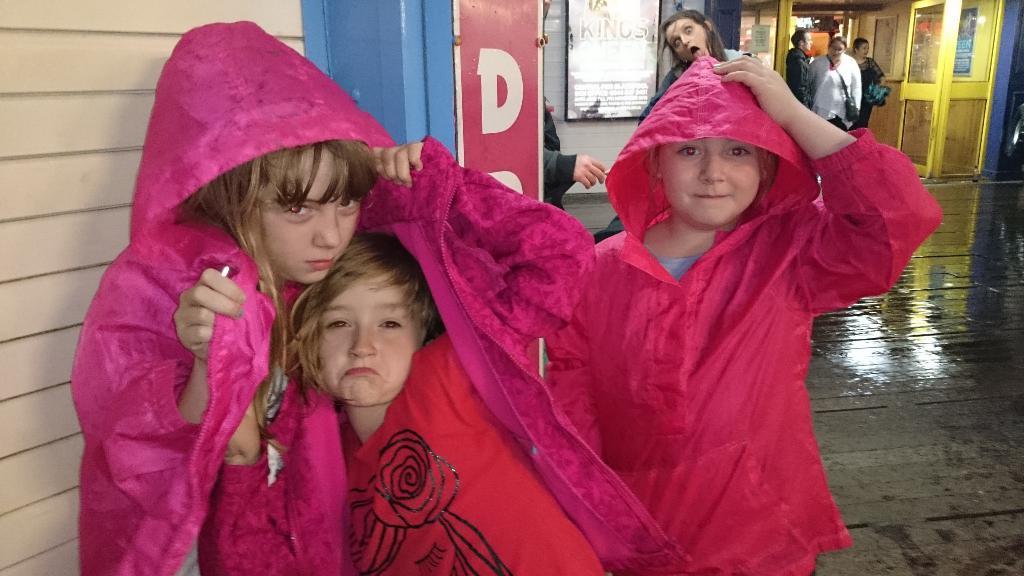Could you give a brief overview of what you see in this image? In this image there are a few children's and few people are standing and few are walking from the entrance of the one of the buildings and there is a board with some text. 